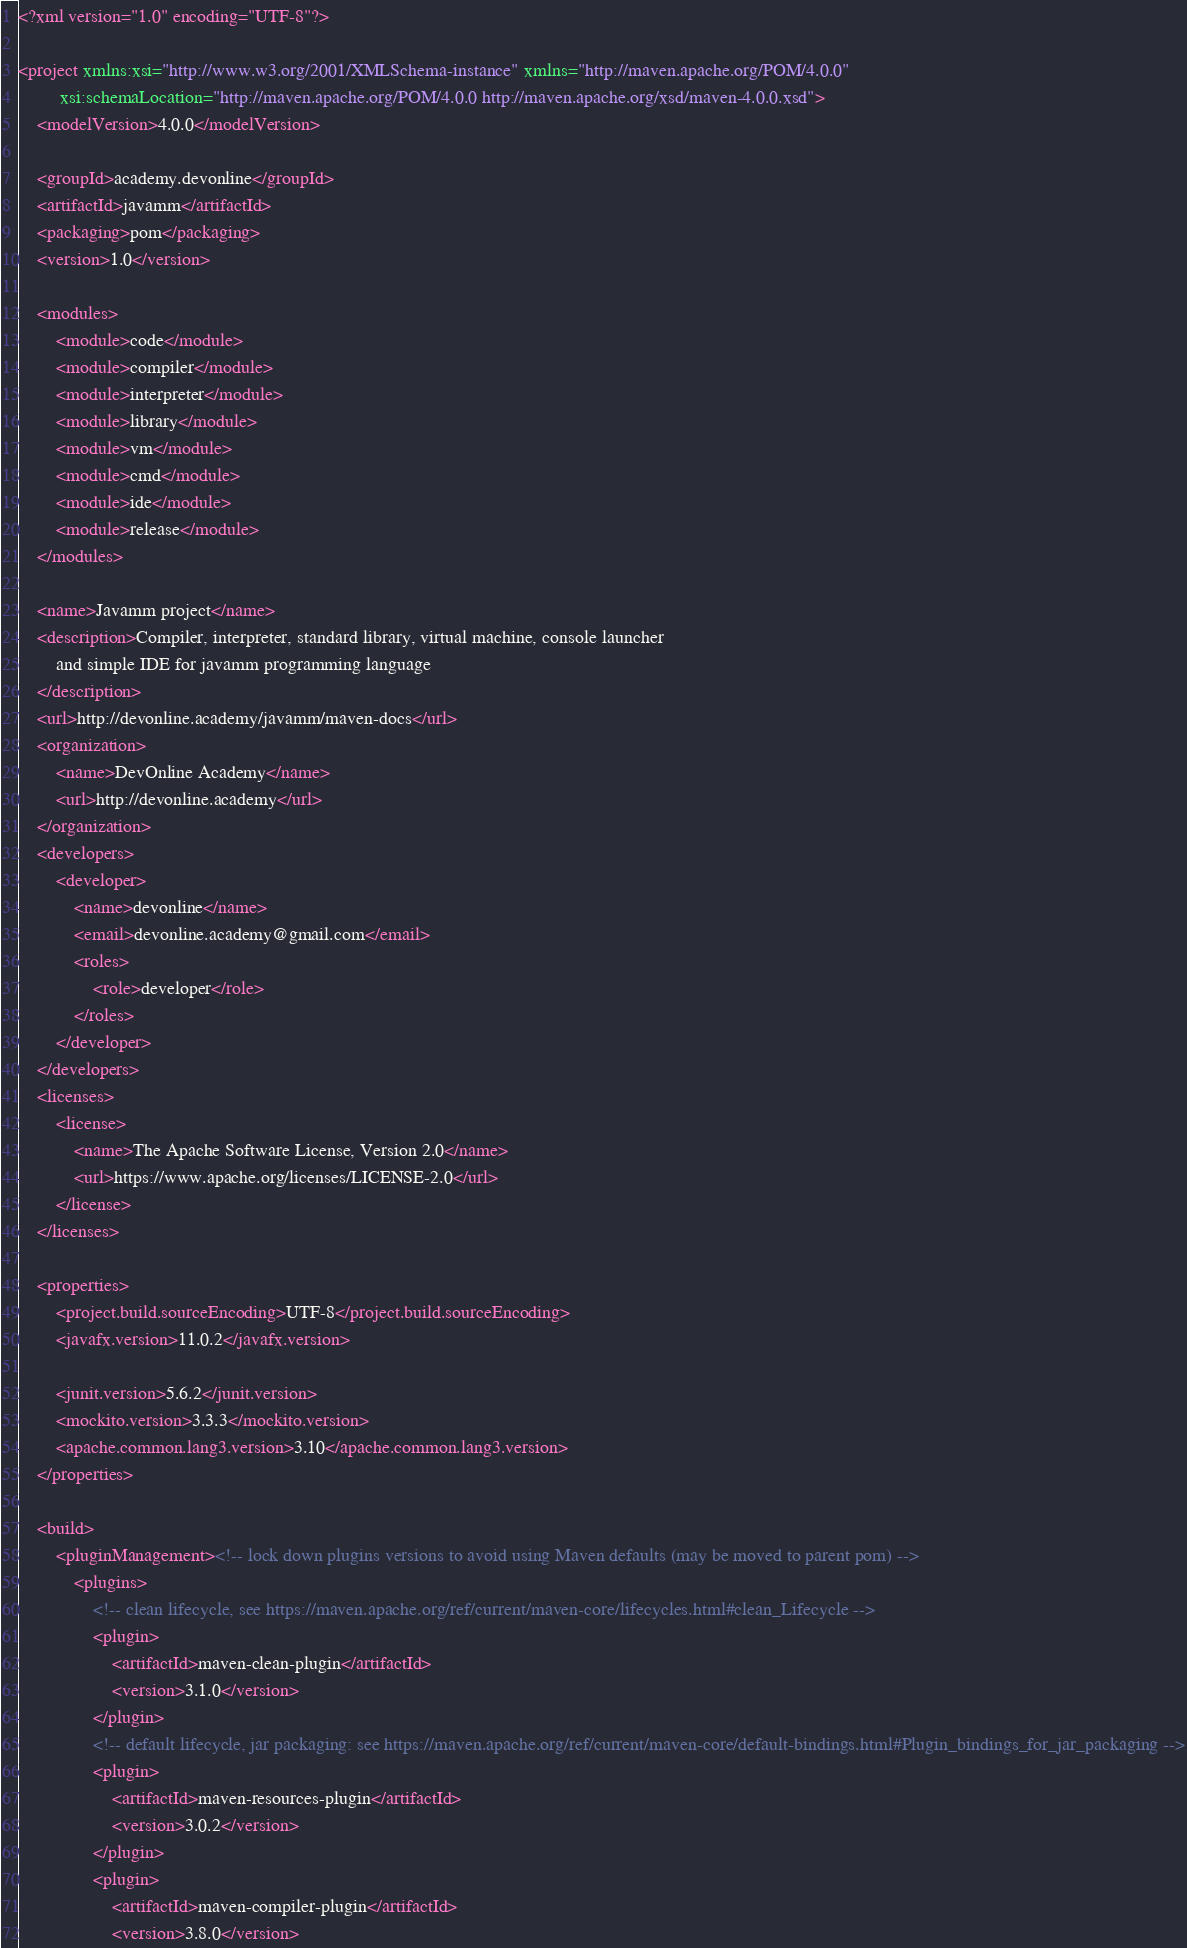Convert code to text. <code><loc_0><loc_0><loc_500><loc_500><_XML_><?xml version="1.0" encoding="UTF-8"?>

<project xmlns:xsi="http://www.w3.org/2001/XMLSchema-instance" xmlns="http://maven.apache.org/POM/4.0.0"
         xsi:schemaLocation="http://maven.apache.org/POM/4.0.0 http://maven.apache.org/xsd/maven-4.0.0.xsd">
    <modelVersion>4.0.0</modelVersion>

    <groupId>academy.devonline</groupId>
    <artifactId>javamm</artifactId>
    <packaging>pom</packaging>
    <version>1.0</version>

    <modules>
        <module>code</module>
        <module>compiler</module>
        <module>interpreter</module>
        <module>library</module>
        <module>vm</module>
        <module>cmd</module>
        <module>ide</module>
        <module>release</module>
    </modules>

    <name>Javamm project</name>
    <description>Compiler, interpreter, standard library, virtual machine, console launcher
        and simple IDE for javamm programming language
    </description>
    <url>http://devonline.academy/javamm/maven-docs</url>
    <organization>
        <name>DevOnline Academy</name>
        <url>http://devonline.academy</url>
    </organization>
    <developers>
        <developer>
            <name>devonline</name>
            <email>devonline.academy@gmail.com</email>
            <roles>
                <role>developer</role>
            </roles>
        </developer>
    </developers>
    <licenses>
        <license>
            <name>The Apache Software License, Version 2.0</name>
            <url>https://www.apache.org/licenses/LICENSE-2.0</url>
        </license>
    </licenses>

    <properties>
        <project.build.sourceEncoding>UTF-8</project.build.sourceEncoding>
        <javafx.version>11.0.2</javafx.version>

        <junit.version>5.6.2</junit.version>
        <mockito.version>3.3.3</mockito.version>
        <apache.common.lang3.version>3.10</apache.common.lang3.version>
    </properties>

    <build>
        <pluginManagement><!-- lock down plugins versions to avoid using Maven defaults (may be moved to parent pom) -->
            <plugins>
                <!-- clean lifecycle, see https://maven.apache.org/ref/current/maven-core/lifecycles.html#clean_Lifecycle -->
                <plugin>
                    <artifactId>maven-clean-plugin</artifactId>
                    <version>3.1.0</version>
                </plugin>
                <!-- default lifecycle, jar packaging: see https://maven.apache.org/ref/current/maven-core/default-bindings.html#Plugin_bindings_for_jar_packaging -->
                <plugin>
                    <artifactId>maven-resources-plugin</artifactId>
                    <version>3.0.2</version>
                </plugin>
                <plugin>
                    <artifactId>maven-compiler-plugin</artifactId>
                    <version>3.8.0</version></code> 